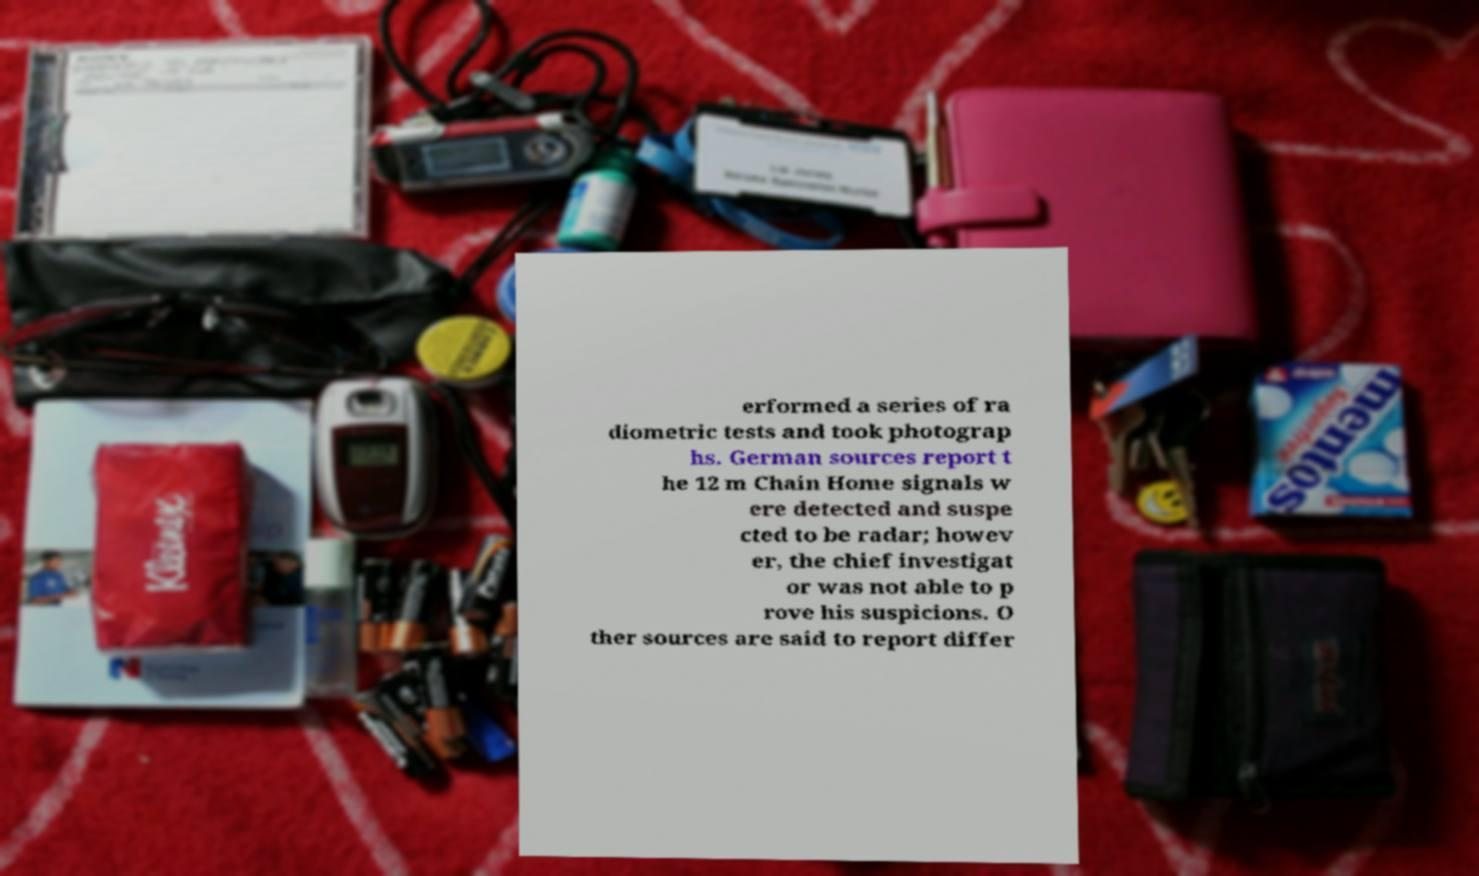I need the written content from this picture converted into text. Can you do that? erformed a series of ra diometric tests and took photograp hs. German sources report t he 12 m Chain Home signals w ere detected and suspe cted to be radar; howev er, the chief investigat or was not able to p rove his suspicions. O ther sources are said to report differ 